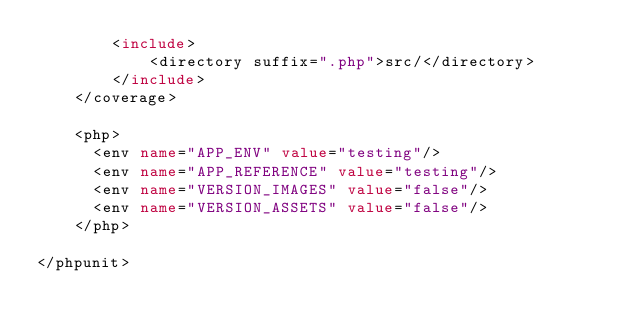Convert code to text. <code><loc_0><loc_0><loc_500><loc_500><_XML_>        <include>
            <directory suffix=".php">src/</directory>
        </include>
    </coverage>

    <php>
      <env name="APP_ENV" value="testing"/>
      <env name="APP_REFERENCE" value="testing"/>
      <env name="VERSION_IMAGES" value="false"/>
      <env name="VERSION_ASSETS" value="false"/>
    </php>

</phpunit>
</code> 